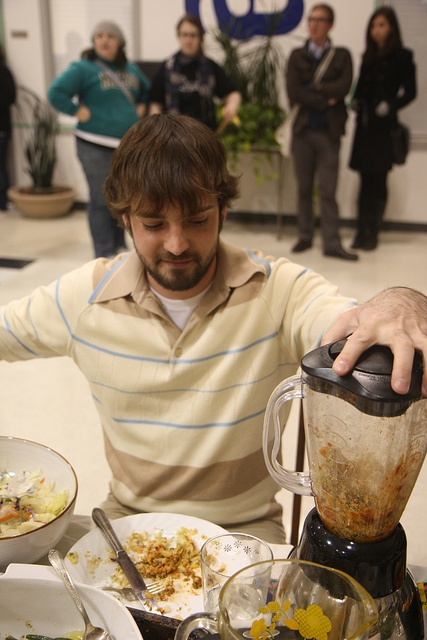Describe the objects in this image and their specific colors. I can see people in gray, tan, and black tones, people in gray, black, and maroon tones, cup in gray, olive, tan, and black tones, bowl in gray, lightgray, and tan tones, and people in gray, black, and maroon tones in this image. 